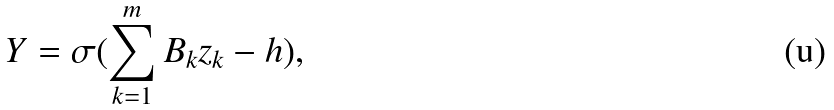<formula> <loc_0><loc_0><loc_500><loc_500>Y = \sigma ( \sum _ { k = 1 } ^ { m } B _ { k } z _ { k } - h ) ,</formula> 